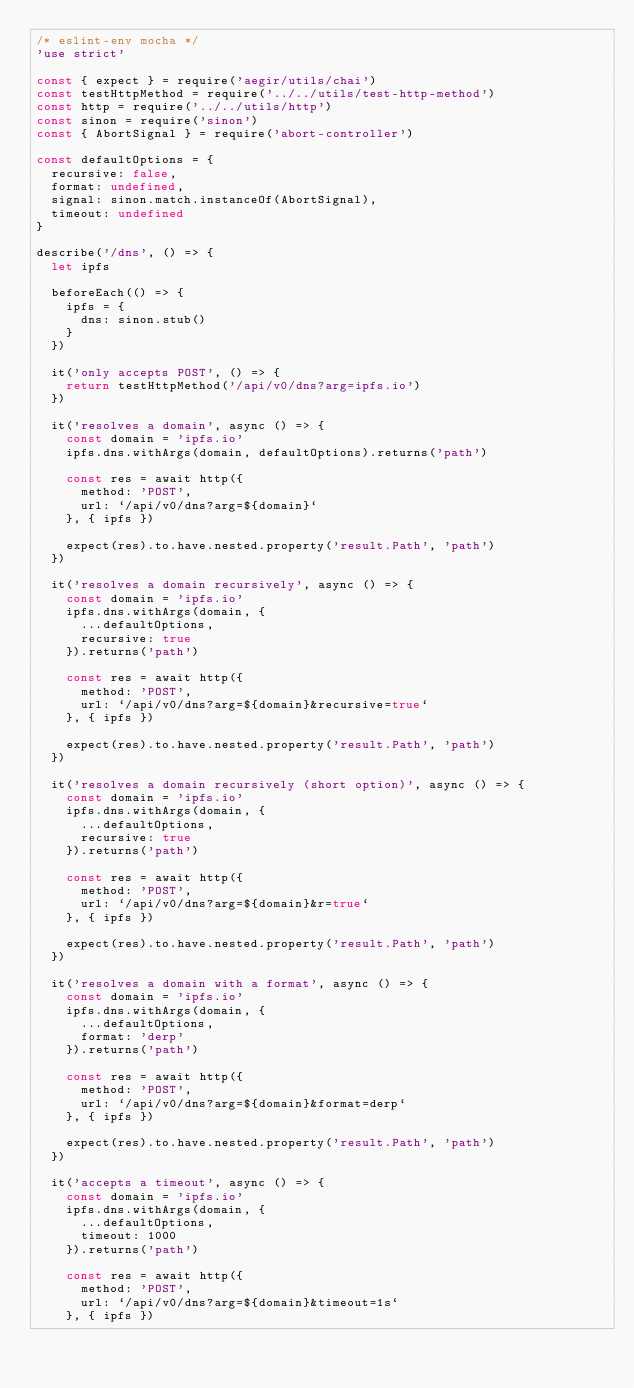<code> <loc_0><loc_0><loc_500><loc_500><_JavaScript_>/* eslint-env mocha */
'use strict'

const { expect } = require('aegir/utils/chai')
const testHttpMethod = require('../../utils/test-http-method')
const http = require('../../utils/http')
const sinon = require('sinon')
const { AbortSignal } = require('abort-controller')

const defaultOptions = {
  recursive: false,
  format: undefined,
  signal: sinon.match.instanceOf(AbortSignal),
  timeout: undefined
}

describe('/dns', () => {
  let ipfs

  beforeEach(() => {
    ipfs = {
      dns: sinon.stub()
    }
  })

  it('only accepts POST', () => {
    return testHttpMethod('/api/v0/dns?arg=ipfs.io')
  })

  it('resolves a domain', async () => {
    const domain = 'ipfs.io'
    ipfs.dns.withArgs(domain, defaultOptions).returns('path')

    const res = await http({
      method: 'POST',
      url: `/api/v0/dns?arg=${domain}`
    }, { ipfs })

    expect(res).to.have.nested.property('result.Path', 'path')
  })

  it('resolves a domain recursively', async () => {
    const domain = 'ipfs.io'
    ipfs.dns.withArgs(domain, {
      ...defaultOptions,
      recursive: true
    }).returns('path')

    const res = await http({
      method: 'POST',
      url: `/api/v0/dns?arg=${domain}&recursive=true`
    }, { ipfs })

    expect(res).to.have.nested.property('result.Path', 'path')
  })

  it('resolves a domain recursively (short option)', async () => {
    const domain = 'ipfs.io'
    ipfs.dns.withArgs(domain, {
      ...defaultOptions,
      recursive: true
    }).returns('path')

    const res = await http({
      method: 'POST',
      url: `/api/v0/dns?arg=${domain}&r=true`
    }, { ipfs })

    expect(res).to.have.nested.property('result.Path', 'path')
  })

  it('resolves a domain with a format', async () => {
    const domain = 'ipfs.io'
    ipfs.dns.withArgs(domain, {
      ...defaultOptions,
      format: 'derp'
    }).returns('path')

    const res = await http({
      method: 'POST',
      url: `/api/v0/dns?arg=${domain}&format=derp`
    }, { ipfs })

    expect(res).to.have.nested.property('result.Path', 'path')
  })

  it('accepts a timeout', async () => {
    const domain = 'ipfs.io'
    ipfs.dns.withArgs(domain, {
      ...defaultOptions,
      timeout: 1000
    }).returns('path')

    const res = await http({
      method: 'POST',
      url: `/api/v0/dns?arg=${domain}&timeout=1s`
    }, { ipfs })
</code> 